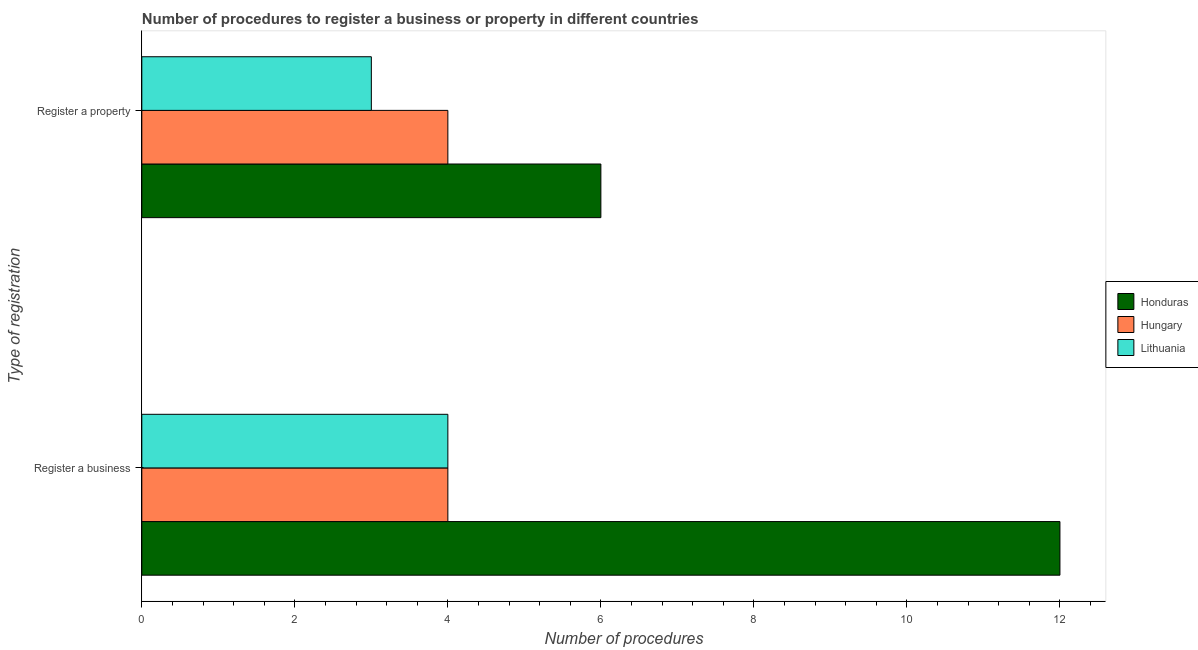How many groups of bars are there?
Your answer should be compact. 2. How many bars are there on the 2nd tick from the bottom?
Keep it short and to the point. 3. What is the label of the 1st group of bars from the top?
Offer a terse response. Register a property. What is the number of procedures to register a business in Honduras?
Keep it short and to the point. 12. Across all countries, what is the maximum number of procedures to register a business?
Your answer should be very brief. 12. Across all countries, what is the minimum number of procedures to register a property?
Provide a succinct answer. 3. In which country was the number of procedures to register a property maximum?
Ensure brevity in your answer.  Honduras. In which country was the number of procedures to register a business minimum?
Your answer should be compact. Hungary. What is the total number of procedures to register a property in the graph?
Make the answer very short. 13. What is the difference between the number of procedures to register a business in Honduras and that in Lithuania?
Keep it short and to the point. 8. What is the difference between the number of procedures to register a business in Honduras and the number of procedures to register a property in Hungary?
Your answer should be compact. 8. What is the average number of procedures to register a business per country?
Offer a very short reply. 6.67. What is the difference between the number of procedures to register a business and number of procedures to register a property in Honduras?
Your response must be concise. 6. In how many countries, is the number of procedures to register a business greater than 3.6 ?
Your response must be concise. 3. What is the ratio of the number of procedures to register a property in Honduras to that in Lithuania?
Offer a terse response. 2. Is the number of procedures to register a property in Hungary less than that in Lithuania?
Ensure brevity in your answer.  No. What does the 1st bar from the top in Register a property represents?
Provide a succinct answer. Lithuania. What does the 1st bar from the bottom in Register a property represents?
Ensure brevity in your answer.  Honduras. How many countries are there in the graph?
Your response must be concise. 3. Does the graph contain any zero values?
Keep it short and to the point. No. How many legend labels are there?
Make the answer very short. 3. How are the legend labels stacked?
Provide a short and direct response. Vertical. What is the title of the graph?
Make the answer very short. Number of procedures to register a business or property in different countries. What is the label or title of the X-axis?
Give a very brief answer. Number of procedures. What is the label or title of the Y-axis?
Offer a very short reply. Type of registration. What is the Number of procedures of Honduras in Register a business?
Offer a very short reply. 12. What is the Number of procedures in Hungary in Register a business?
Give a very brief answer. 4. What is the Number of procedures in Hungary in Register a property?
Offer a very short reply. 4. What is the Number of procedures in Lithuania in Register a property?
Provide a short and direct response. 3. Across all Type of registration, what is the maximum Number of procedures of Lithuania?
Make the answer very short. 4. Across all Type of registration, what is the minimum Number of procedures in Honduras?
Your answer should be compact. 6. What is the total Number of procedures in Honduras in the graph?
Your answer should be compact. 18. What is the total Number of procedures of Hungary in the graph?
Offer a very short reply. 8. What is the total Number of procedures in Lithuania in the graph?
Your response must be concise. 7. What is the difference between the Number of procedures of Honduras in Register a business and that in Register a property?
Your answer should be very brief. 6. What is the difference between the Number of procedures of Lithuania in Register a business and that in Register a property?
Your answer should be very brief. 1. What is the difference between the Number of procedures in Hungary in Register a business and the Number of procedures in Lithuania in Register a property?
Ensure brevity in your answer.  1. What is the average Number of procedures of Honduras per Type of registration?
Provide a succinct answer. 9. What is the difference between the Number of procedures in Honduras and Number of procedures in Hungary in Register a business?
Your answer should be compact. 8. What is the difference between the Number of procedures in Honduras and Number of procedures in Lithuania in Register a business?
Make the answer very short. 8. What is the difference between the Number of procedures in Honduras and Number of procedures in Hungary in Register a property?
Provide a succinct answer. 2. What is the difference between the Number of procedures of Honduras and Number of procedures of Lithuania in Register a property?
Make the answer very short. 3. What is the ratio of the Number of procedures of Hungary in Register a business to that in Register a property?
Ensure brevity in your answer.  1. What is the difference between the highest and the second highest Number of procedures in Hungary?
Provide a short and direct response. 0. What is the difference between the highest and the second highest Number of procedures of Lithuania?
Provide a short and direct response. 1. What is the difference between the highest and the lowest Number of procedures in Hungary?
Offer a very short reply. 0. 